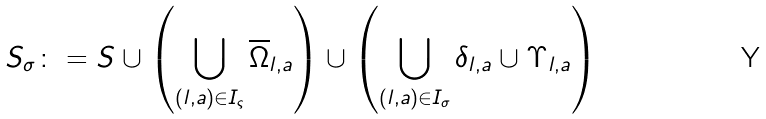<formula> <loc_0><loc_0><loc_500><loc_500>S _ { \sigma } \colon = S \cup \left ( \bigcup _ { ( l , a ) \in I _ { \varsigma } } \overline { \Omega } _ { l , a } \right ) \cup \left ( \bigcup _ { ( l , a ) \in I _ { \sigma } } \delta _ { l , a } \cup \Upsilon _ { l , a } \right )</formula> 